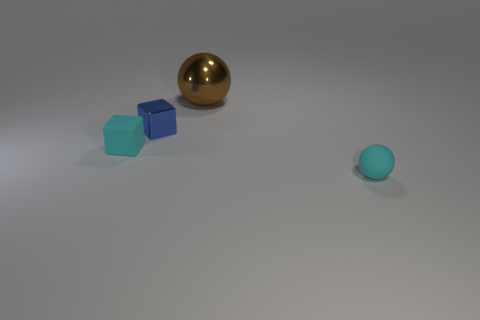Subtract 2 balls. How many balls are left? 0 Add 4 big cyan rubber balls. How many objects exist? 8 Subtract all cyan balls. How many balls are left? 1 Subtract all small cyan matte cubes. Subtract all tiny matte things. How many objects are left? 1 Add 4 tiny blue metal things. How many tiny blue metal things are left? 5 Add 2 small purple shiny cylinders. How many small purple shiny cylinders exist? 2 Subtract 0 blue cylinders. How many objects are left? 4 Subtract all cyan cubes. Subtract all yellow cylinders. How many cubes are left? 1 Subtract all cyan spheres. How many yellow blocks are left? 0 